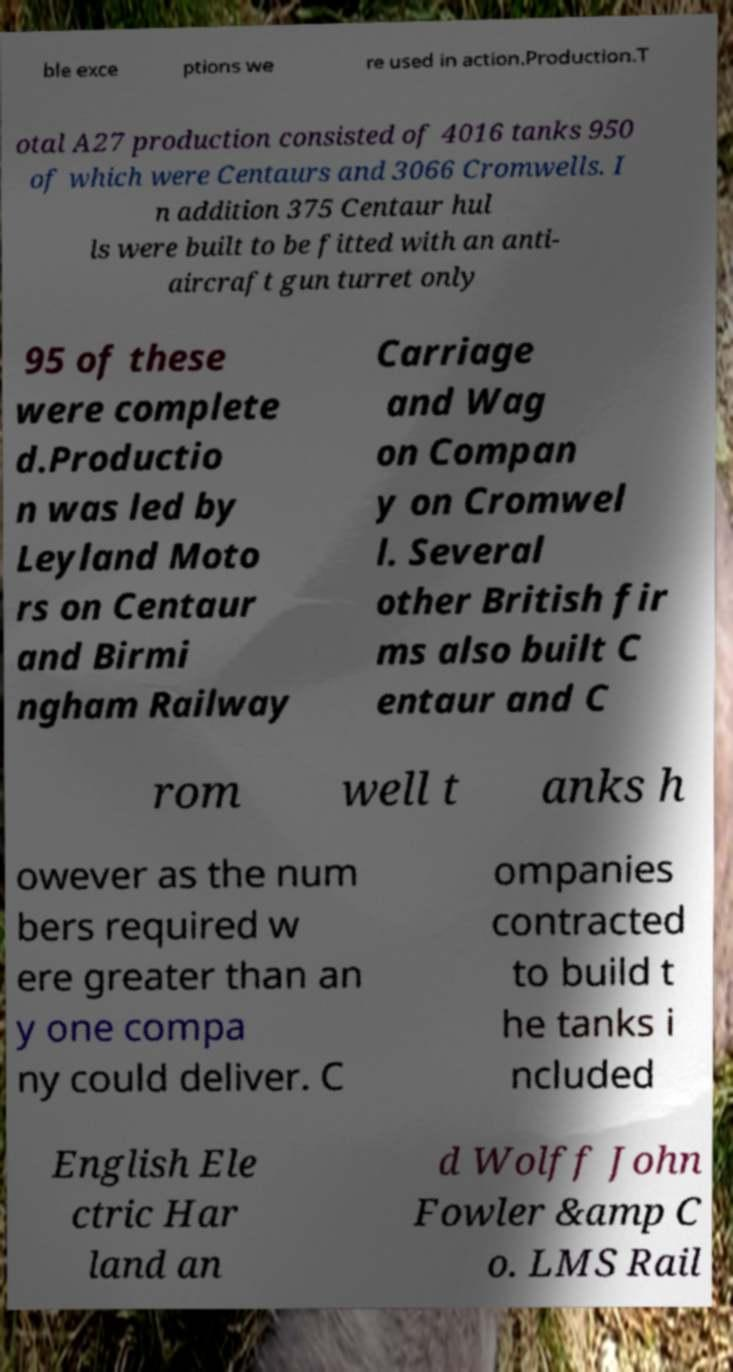Could you extract and type out the text from this image? ble exce ptions we re used in action.Production.T otal A27 production consisted of 4016 tanks 950 of which were Centaurs and 3066 Cromwells. I n addition 375 Centaur hul ls were built to be fitted with an anti- aircraft gun turret only 95 of these were complete d.Productio n was led by Leyland Moto rs on Centaur and Birmi ngham Railway Carriage and Wag on Compan y on Cromwel l. Several other British fir ms also built C entaur and C rom well t anks h owever as the num bers required w ere greater than an y one compa ny could deliver. C ompanies contracted to build t he tanks i ncluded English Ele ctric Har land an d Wolff John Fowler &amp C o. LMS Rail 